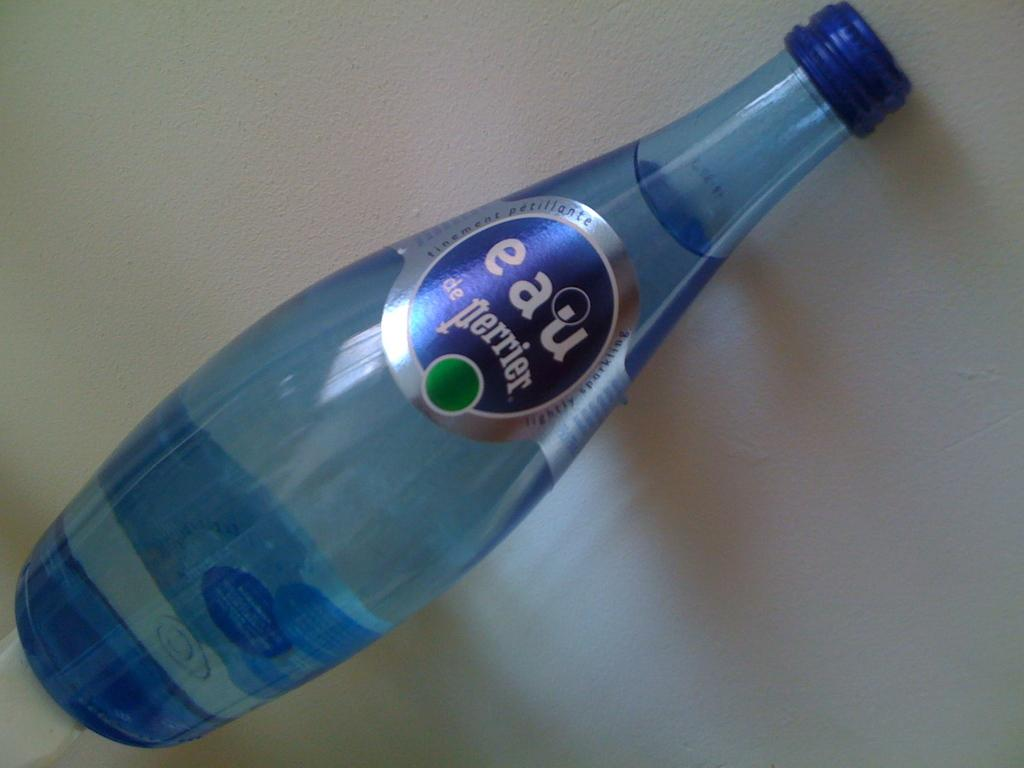What is the main object in the center of the image? There is a water bottle in the center of the image. What type of milk is being poured from the water bottle in the image? There is no milk present in the image; it is a water bottle. What is the temper of the water in the bottle? The provided facts do not mention the temperature of the water in the bottle, so it cannot be determined from the image. 